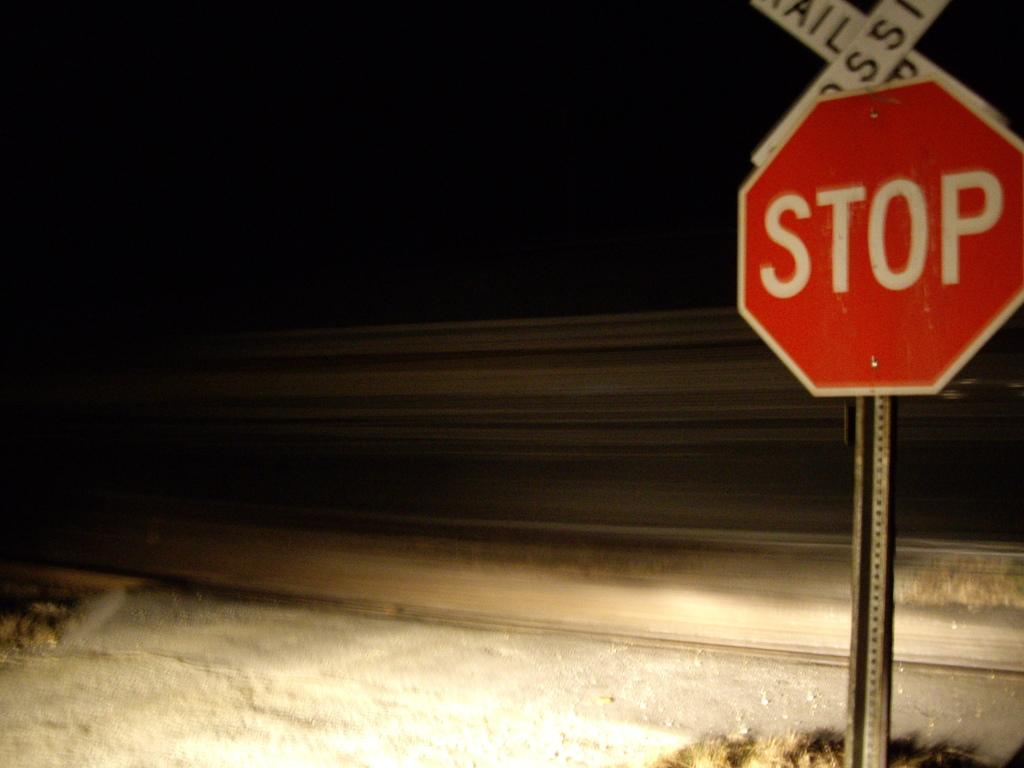<image>
Write a terse but informative summary of the picture. A stop sign with railroad crossing sign sits in the dark. 